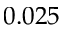<formula> <loc_0><loc_0><loc_500><loc_500>0 . 0 2 5</formula> 